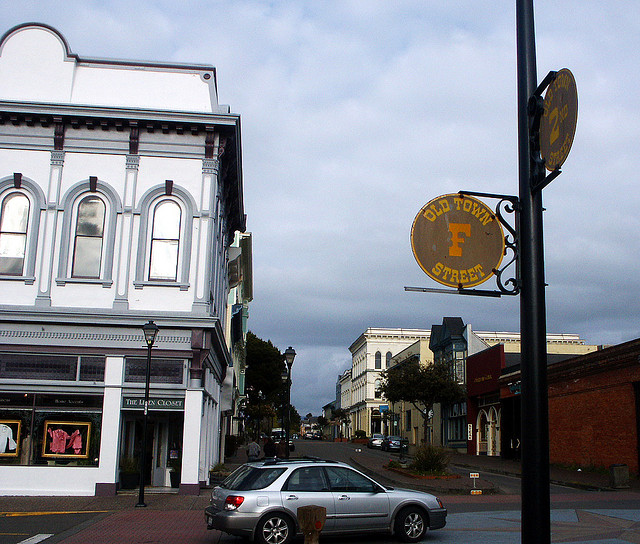Read and extract the text from this image. STREET F OLD TOWN STREET OLD 2ND THE 